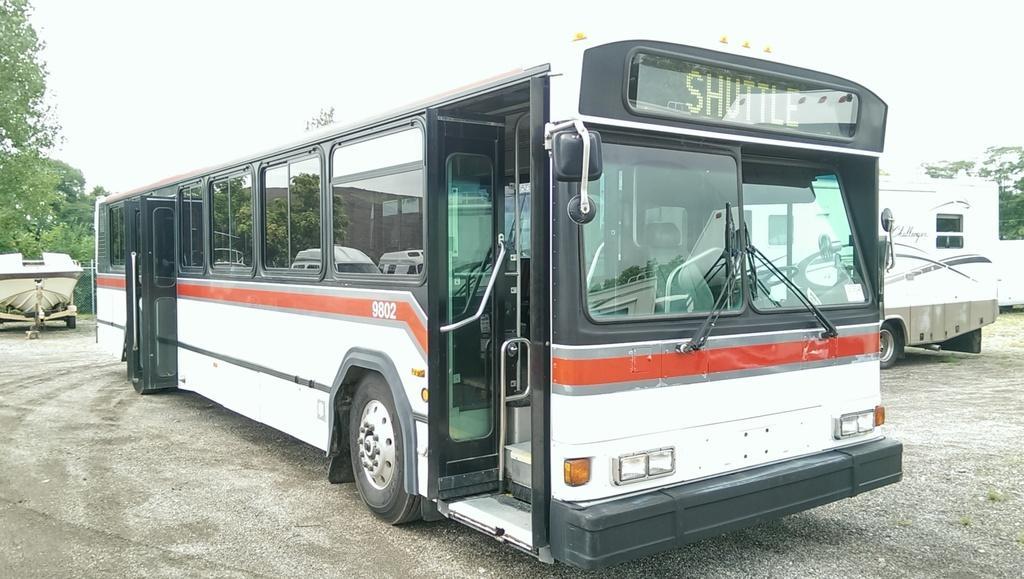How would you summarize this image in a sentence or two? In this image there are vehicles parked on the ground. In the center there is a bus. There is a digital display board to the bus. In the background there are trees. At the top there is the sky. 